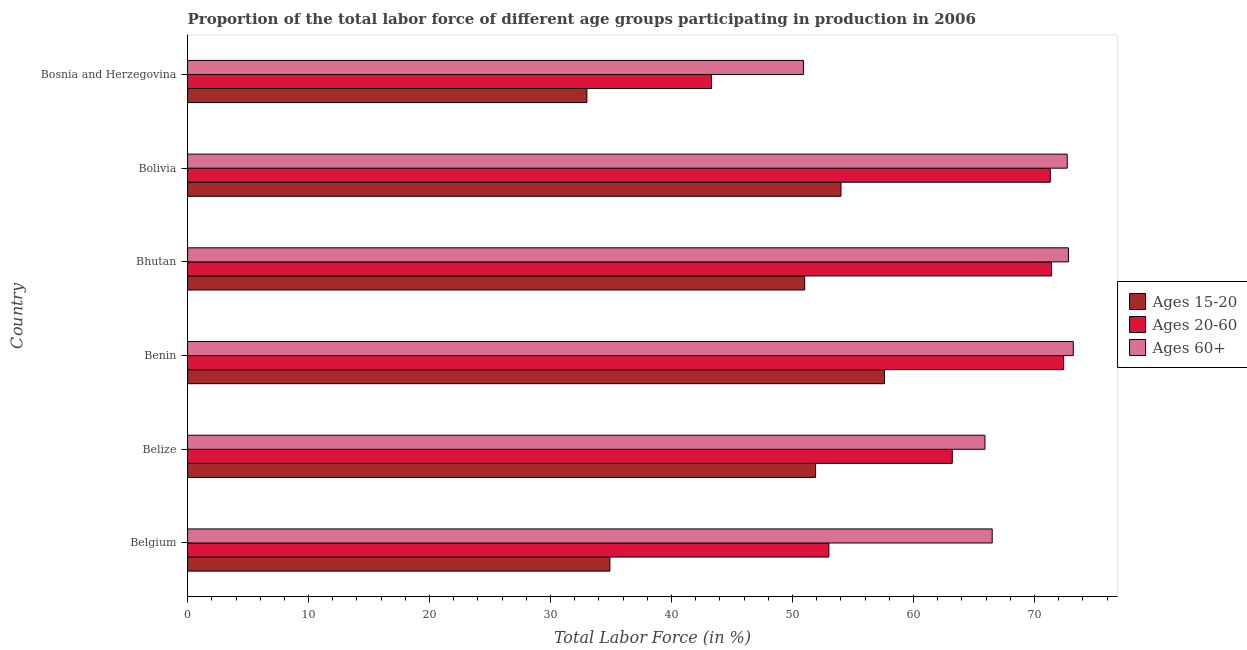How many different coloured bars are there?
Offer a terse response. 3. How many groups of bars are there?
Offer a very short reply. 6. Are the number of bars per tick equal to the number of legend labels?
Offer a very short reply. Yes. How many bars are there on the 5th tick from the top?
Provide a short and direct response. 3. How many bars are there on the 6th tick from the bottom?
Offer a very short reply. 3. What is the label of the 4th group of bars from the top?
Your answer should be very brief. Benin. What is the percentage of labor force within the age group 15-20 in Bosnia and Herzegovina?
Your answer should be very brief. 33. Across all countries, what is the maximum percentage of labor force within the age group 20-60?
Provide a succinct answer. 72.4. In which country was the percentage of labor force within the age group 20-60 maximum?
Your response must be concise. Benin. In which country was the percentage of labor force within the age group 20-60 minimum?
Provide a succinct answer. Bosnia and Herzegovina. What is the total percentage of labor force within the age group 15-20 in the graph?
Make the answer very short. 282.4. What is the difference between the percentage of labor force within the age group 15-20 in Bosnia and Herzegovina and the percentage of labor force within the age group 20-60 in Bolivia?
Make the answer very short. -38.3. What is the average percentage of labor force within the age group 20-60 per country?
Provide a succinct answer. 62.43. What is the difference between the percentage of labor force within the age group 15-20 and percentage of labor force above age 60 in Belize?
Give a very brief answer. -14. In how many countries, is the percentage of labor force within the age group 20-60 greater than 62 %?
Your answer should be very brief. 4. What is the ratio of the percentage of labor force within the age group 15-20 in Belgium to that in Benin?
Make the answer very short. 0.61. Is the percentage of labor force above age 60 in Bhutan less than that in Bosnia and Herzegovina?
Your answer should be compact. No. What is the difference between the highest and the lowest percentage of labor force within the age group 15-20?
Give a very brief answer. 24.6. In how many countries, is the percentage of labor force within the age group 15-20 greater than the average percentage of labor force within the age group 15-20 taken over all countries?
Your response must be concise. 4. What does the 2nd bar from the top in Benin represents?
Your answer should be very brief. Ages 20-60. What does the 3rd bar from the bottom in Bolivia represents?
Offer a terse response. Ages 60+. How many bars are there?
Provide a succinct answer. 18. Are all the bars in the graph horizontal?
Your answer should be very brief. Yes. How many countries are there in the graph?
Ensure brevity in your answer.  6. Where does the legend appear in the graph?
Keep it short and to the point. Center right. How many legend labels are there?
Make the answer very short. 3. What is the title of the graph?
Keep it short and to the point. Proportion of the total labor force of different age groups participating in production in 2006. What is the label or title of the X-axis?
Your response must be concise. Total Labor Force (in %). What is the label or title of the Y-axis?
Your answer should be compact. Country. What is the Total Labor Force (in %) in Ages 15-20 in Belgium?
Keep it short and to the point. 34.9. What is the Total Labor Force (in %) in Ages 60+ in Belgium?
Keep it short and to the point. 66.5. What is the Total Labor Force (in %) of Ages 15-20 in Belize?
Offer a very short reply. 51.9. What is the Total Labor Force (in %) of Ages 20-60 in Belize?
Offer a terse response. 63.2. What is the Total Labor Force (in %) in Ages 60+ in Belize?
Offer a very short reply. 65.9. What is the Total Labor Force (in %) of Ages 15-20 in Benin?
Your response must be concise. 57.6. What is the Total Labor Force (in %) of Ages 20-60 in Benin?
Your answer should be very brief. 72.4. What is the Total Labor Force (in %) in Ages 60+ in Benin?
Your answer should be compact. 73.2. What is the Total Labor Force (in %) in Ages 20-60 in Bhutan?
Offer a terse response. 71.4. What is the Total Labor Force (in %) in Ages 60+ in Bhutan?
Provide a short and direct response. 72.8. What is the Total Labor Force (in %) of Ages 15-20 in Bolivia?
Offer a terse response. 54. What is the Total Labor Force (in %) of Ages 20-60 in Bolivia?
Provide a succinct answer. 71.3. What is the Total Labor Force (in %) in Ages 60+ in Bolivia?
Make the answer very short. 72.7. What is the Total Labor Force (in %) in Ages 20-60 in Bosnia and Herzegovina?
Ensure brevity in your answer.  43.3. What is the Total Labor Force (in %) of Ages 60+ in Bosnia and Herzegovina?
Make the answer very short. 50.9. Across all countries, what is the maximum Total Labor Force (in %) of Ages 15-20?
Give a very brief answer. 57.6. Across all countries, what is the maximum Total Labor Force (in %) in Ages 20-60?
Give a very brief answer. 72.4. Across all countries, what is the maximum Total Labor Force (in %) in Ages 60+?
Keep it short and to the point. 73.2. Across all countries, what is the minimum Total Labor Force (in %) of Ages 20-60?
Your response must be concise. 43.3. Across all countries, what is the minimum Total Labor Force (in %) of Ages 60+?
Ensure brevity in your answer.  50.9. What is the total Total Labor Force (in %) of Ages 15-20 in the graph?
Keep it short and to the point. 282.4. What is the total Total Labor Force (in %) in Ages 20-60 in the graph?
Offer a terse response. 374.6. What is the total Total Labor Force (in %) of Ages 60+ in the graph?
Provide a short and direct response. 402. What is the difference between the Total Labor Force (in %) in Ages 15-20 in Belgium and that in Belize?
Your answer should be very brief. -17. What is the difference between the Total Labor Force (in %) in Ages 20-60 in Belgium and that in Belize?
Offer a terse response. -10.2. What is the difference between the Total Labor Force (in %) in Ages 60+ in Belgium and that in Belize?
Provide a succinct answer. 0.6. What is the difference between the Total Labor Force (in %) in Ages 15-20 in Belgium and that in Benin?
Provide a succinct answer. -22.7. What is the difference between the Total Labor Force (in %) in Ages 20-60 in Belgium and that in Benin?
Give a very brief answer. -19.4. What is the difference between the Total Labor Force (in %) in Ages 15-20 in Belgium and that in Bhutan?
Your answer should be very brief. -16.1. What is the difference between the Total Labor Force (in %) of Ages 20-60 in Belgium and that in Bhutan?
Ensure brevity in your answer.  -18.4. What is the difference between the Total Labor Force (in %) in Ages 15-20 in Belgium and that in Bolivia?
Offer a terse response. -19.1. What is the difference between the Total Labor Force (in %) of Ages 20-60 in Belgium and that in Bolivia?
Keep it short and to the point. -18.3. What is the difference between the Total Labor Force (in %) in Ages 60+ in Belgium and that in Bolivia?
Make the answer very short. -6.2. What is the difference between the Total Labor Force (in %) of Ages 15-20 in Belgium and that in Bosnia and Herzegovina?
Make the answer very short. 1.9. What is the difference between the Total Labor Force (in %) of Ages 20-60 in Belgium and that in Bosnia and Herzegovina?
Keep it short and to the point. 9.7. What is the difference between the Total Labor Force (in %) in Ages 60+ in Belize and that in Benin?
Make the answer very short. -7.3. What is the difference between the Total Labor Force (in %) of Ages 15-20 in Belize and that in Bhutan?
Give a very brief answer. 0.9. What is the difference between the Total Labor Force (in %) of Ages 15-20 in Belize and that in Bolivia?
Your response must be concise. -2.1. What is the difference between the Total Labor Force (in %) of Ages 60+ in Belize and that in Bolivia?
Keep it short and to the point. -6.8. What is the difference between the Total Labor Force (in %) of Ages 15-20 in Benin and that in Bhutan?
Provide a succinct answer. 6.6. What is the difference between the Total Labor Force (in %) of Ages 15-20 in Benin and that in Bolivia?
Provide a succinct answer. 3.6. What is the difference between the Total Labor Force (in %) in Ages 20-60 in Benin and that in Bolivia?
Provide a succinct answer. 1.1. What is the difference between the Total Labor Force (in %) in Ages 15-20 in Benin and that in Bosnia and Herzegovina?
Your response must be concise. 24.6. What is the difference between the Total Labor Force (in %) in Ages 20-60 in Benin and that in Bosnia and Herzegovina?
Your answer should be compact. 29.1. What is the difference between the Total Labor Force (in %) in Ages 60+ in Benin and that in Bosnia and Herzegovina?
Offer a terse response. 22.3. What is the difference between the Total Labor Force (in %) in Ages 15-20 in Bhutan and that in Bolivia?
Your answer should be compact. -3. What is the difference between the Total Labor Force (in %) of Ages 15-20 in Bhutan and that in Bosnia and Herzegovina?
Offer a very short reply. 18. What is the difference between the Total Labor Force (in %) of Ages 20-60 in Bhutan and that in Bosnia and Herzegovina?
Make the answer very short. 28.1. What is the difference between the Total Labor Force (in %) of Ages 60+ in Bhutan and that in Bosnia and Herzegovina?
Provide a succinct answer. 21.9. What is the difference between the Total Labor Force (in %) in Ages 15-20 in Bolivia and that in Bosnia and Herzegovina?
Provide a short and direct response. 21. What is the difference between the Total Labor Force (in %) in Ages 20-60 in Bolivia and that in Bosnia and Herzegovina?
Offer a terse response. 28. What is the difference between the Total Labor Force (in %) of Ages 60+ in Bolivia and that in Bosnia and Herzegovina?
Offer a terse response. 21.8. What is the difference between the Total Labor Force (in %) in Ages 15-20 in Belgium and the Total Labor Force (in %) in Ages 20-60 in Belize?
Provide a short and direct response. -28.3. What is the difference between the Total Labor Force (in %) in Ages 15-20 in Belgium and the Total Labor Force (in %) in Ages 60+ in Belize?
Give a very brief answer. -31. What is the difference between the Total Labor Force (in %) of Ages 20-60 in Belgium and the Total Labor Force (in %) of Ages 60+ in Belize?
Offer a very short reply. -12.9. What is the difference between the Total Labor Force (in %) in Ages 15-20 in Belgium and the Total Labor Force (in %) in Ages 20-60 in Benin?
Provide a succinct answer. -37.5. What is the difference between the Total Labor Force (in %) in Ages 15-20 in Belgium and the Total Labor Force (in %) in Ages 60+ in Benin?
Make the answer very short. -38.3. What is the difference between the Total Labor Force (in %) of Ages 20-60 in Belgium and the Total Labor Force (in %) of Ages 60+ in Benin?
Ensure brevity in your answer.  -20.2. What is the difference between the Total Labor Force (in %) in Ages 15-20 in Belgium and the Total Labor Force (in %) in Ages 20-60 in Bhutan?
Make the answer very short. -36.5. What is the difference between the Total Labor Force (in %) in Ages 15-20 in Belgium and the Total Labor Force (in %) in Ages 60+ in Bhutan?
Your answer should be very brief. -37.9. What is the difference between the Total Labor Force (in %) of Ages 20-60 in Belgium and the Total Labor Force (in %) of Ages 60+ in Bhutan?
Offer a very short reply. -19.8. What is the difference between the Total Labor Force (in %) in Ages 15-20 in Belgium and the Total Labor Force (in %) in Ages 20-60 in Bolivia?
Your answer should be compact. -36.4. What is the difference between the Total Labor Force (in %) of Ages 15-20 in Belgium and the Total Labor Force (in %) of Ages 60+ in Bolivia?
Offer a terse response. -37.8. What is the difference between the Total Labor Force (in %) of Ages 20-60 in Belgium and the Total Labor Force (in %) of Ages 60+ in Bolivia?
Make the answer very short. -19.7. What is the difference between the Total Labor Force (in %) of Ages 15-20 in Belgium and the Total Labor Force (in %) of Ages 20-60 in Bosnia and Herzegovina?
Your answer should be compact. -8.4. What is the difference between the Total Labor Force (in %) in Ages 15-20 in Belgium and the Total Labor Force (in %) in Ages 60+ in Bosnia and Herzegovina?
Make the answer very short. -16. What is the difference between the Total Labor Force (in %) in Ages 20-60 in Belgium and the Total Labor Force (in %) in Ages 60+ in Bosnia and Herzegovina?
Offer a terse response. 2.1. What is the difference between the Total Labor Force (in %) of Ages 15-20 in Belize and the Total Labor Force (in %) of Ages 20-60 in Benin?
Make the answer very short. -20.5. What is the difference between the Total Labor Force (in %) in Ages 15-20 in Belize and the Total Labor Force (in %) in Ages 60+ in Benin?
Ensure brevity in your answer.  -21.3. What is the difference between the Total Labor Force (in %) of Ages 15-20 in Belize and the Total Labor Force (in %) of Ages 20-60 in Bhutan?
Your response must be concise. -19.5. What is the difference between the Total Labor Force (in %) in Ages 15-20 in Belize and the Total Labor Force (in %) in Ages 60+ in Bhutan?
Provide a short and direct response. -20.9. What is the difference between the Total Labor Force (in %) in Ages 20-60 in Belize and the Total Labor Force (in %) in Ages 60+ in Bhutan?
Ensure brevity in your answer.  -9.6. What is the difference between the Total Labor Force (in %) in Ages 15-20 in Belize and the Total Labor Force (in %) in Ages 20-60 in Bolivia?
Provide a succinct answer. -19.4. What is the difference between the Total Labor Force (in %) in Ages 15-20 in Belize and the Total Labor Force (in %) in Ages 60+ in Bolivia?
Provide a succinct answer. -20.8. What is the difference between the Total Labor Force (in %) in Ages 20-60 in Belize and the Total Labor Force (in %) in Ages 60+ in Bolivia?
Give a very brief answer. -9.5. What is the difference between the Total Labor Force (in %) of Ages 20-60 in Belize and the Total Labor Force (in %) of Ages 60+ in Bosnia and Herzegovina?
Offer a very short reply. 12.3. What is the difference between the Total Labor Force (in %) in Ages 15-20 in Benin and the Total Labor Force (in %) in Ages 60+ in Bhutan?
Give a very brief answer. -15.2. What is the difference between the Total Labor Force (in %) of Ages 20-60 in Benin and the Total Labor Force (in %) of Ages 60+ in Bhutan?
Keep it short and to the point. -0.4. What is the difference between the Total Labor Force (in %) of Ages 15-20 in Benin and the Total Labor Force (in %) of Ages 20-60 in Bolivia?
Offer a very short reply. -13.7. What is the difference between the Total Labor Force (in %) in Ages 15-20 in Benin and the Total Labor Force (in %) in Ages 60+ in Bolivia?
Offer a very short reply. -15.1. What is the difference between the Total Labor Force (in %) of Ages 15-20 in Benin and the Total Labor Force (in %) of Ages 20-60 in Bosnia and Herzegovina?
Provide a succinct answer. 14.3. What is the difference between the Total Labor Force (in %) of Ages 15-20 in Bhutan and the Total Labor Force (in %) of Ages 20-60 in Bolivia?
Keep it short and to the point. -20.3. What is the difference between the Total Labor Force (in %) in Ages 15-20 in Bhutan and the Total Labor Force (in %) in Ages 60+ in Bolivia?
Ensure brevity in your answer.  -21.7. What is the difference between the Total Labor Force (in %) of Ages 15-20 in Bolivia and the Total Labor Force (in %) of Ages 20-60 in Bosnia and Herzegovina?
Make the answer very short. 10.7. What is the difference between the Total Labor Force (in %) of Ages 20-60 in Bolivia and the Total Labor Force (in %) of Ages 60+ in Bosnia and Herzegovina?
Provide a short and direct response. 20.4. What is the average Total Labor Force (in %) of Ages 15-20 per country?
Offer a very short reply. 47.07. What is the average Total Labor Force (in %) of Ages 20-60 per country?
Make the answer very short. 62.43. What is the difference between the Total Labor Force (in %) in Ages 15-20 and Total Labor Force (in %) in Ages 20-60 in Belgium?
Provide a succinct answer. -18.1. What is the difference between the Total Labor Force (in %) in Ages 15-20 and Total Labor Force (in %) in Ages 60+ in Belgium?
Your response must be concise. -31.6. What is the difference between the Total Labor Force (in %) of Ages 15-20 and Total Labor Force (in %) of Ages 60+ in Belize?
Provide a short and direct response. -14. What is the difference between the Total Labor Force (in %) of Ages 15-20 and Total Labor Force (in %) of Ages 20-60 in Benin?
Provide a short and direct response. -14.8. What is the difference between the Total Labor Force (in %) in Ages 15-20 and Total Labor Force (in %) in Ages 60+ in Benin?
Your answer should be compact. -15.6. What is the difference between the Total Labor Force (in %) in Ages 20-60 and Total Labor Force (in %) in Ages 60+ in Benin?
Your answer should be compact. -0.8. What is the difference between the Total Labor Force (in %) of Ages 15-20 and Total Labor Force (in %) of Ages 20-60 in Bhutan?
Ensure brevity in your answer.  -20.4. What is the difference between the Total Labor Force (in %) of Ages 15-20 and Total Labor Force (in %) of Ages 60+ in Bhutan?
Provide a succinct answer. -21.8. What is the difference between the Total Labor Force (in %) in Ages 20-60 and Total Labor Force (in %) in Ages 60+ in Bhutan?
Give a very brief answer. -1.4. What is the difference between the Total Labor Force (in %) in Ages 15-20 and Total Labor Force (in %) in Ages 20-60 in Bolivia?
Offer a very short reply. -17.3. What is the difference between the Total Labor Force (in %) in Ages 15-20 and Total Labor Force (in %) in Ages 60+ in Bolivia?
Provide a succinct answer. -18.7. What is the difference between the Total Labor Force (in %) of Ages 20-60 and Total Labor Force (in %) of Ages 60+ in Bolivia?
Your answer should be very brief. -1.4. What is the difference between the Total Labor Force (in %) of Ages 15-20 and Total Labor Force (in %) of Ages 60+ in Bosnia and Herzegovina?
Your answer should be very brief. -17.9. What is the difference between the Total Labor Force (in %) in Ages 20-60 and Total Labor Force (in %) in Ages 60+ in Bosnia and Herzegovina?
Your response must be concise. -7.6. What is the ratio of the Total Labor Force (in %) of Ages 15-20 in Belgium to that in Belize?
Provide a succinct answer. 0.67. What is the ratio of the Total Labor Force (in %) in Ages 20-60 in Belgium to that in Belize?
Keep it short and to the point. 0.84. What is the ratio of the Total Labor Force (in %) in Ages 60+ in Belgium to that in Belize?
Provide a short and direct response. 1.01. What is the ratio of the Total Labor Force (in %) of Ages 15-20 in Belgium to that in Benin?
Offer a terse response. 0.61. What is the ratio of the Total Labor Force (in %) of Ages 20-60 in Belgium to that in Benin?
Ensure brevity in your answer.  0.73. What is the ratio of the Total Labor Force (in %) of Ages 60+ in Belgium to that in Benin?
Provide a succinct answer. 0.91. What is the ratio of the Total Labor Force (in %) in Ages 15-20 in Belgium to that in Bhutan?
Give a very brief answer. 0.68. What is the ratio of the Total Labor Force (in %) in Ages 20-60 in Belgium to that in Bhutan?
Your response must be concise. 0.74. What is the ratio of the Total Labor Force (in %) in Ages 60+ in Belgium to that in Bhutan?
Your response must be concise. 0.91. What is the ratio of the Total Labor Force (in %) in Ages 15-20 in Belgium to that in Bolivia?
Your answer should be very brief. 0.65. What is the ratio of the Total Labor Force (in %) in Ages 20-60 in Belgium to that in Bolivia?
Offer a terse response. 0.74. What is the ratio of the Total Labor Force (in %) in Ages 60+ in Belgium to that in Bolivia?
Provide a succinct answer. 0.91. What is the ratio of the Total Labor Force (in %) in Ages 15-20 in Belgium to that in Bosnia and Herzegovina?
Provide a succinct answer. 1.06. What is the ratio of the Total Labor Force (in %) of Ages 20-60 in Belgium to that in Bosnia and Herzegovina?
Keep it short and to the point. 1.22. What is the ratio of the Total Labor Force (in %) in Ages 60+ in Belgium to that in Bosnia and Herzegovina?
Provide a short and direct response. 1.31. What is the ratio of the Total Labor Force (in %) of Ages 15-20 in Belize to that in Benin?
Make the answer very short. 0.9. What is the ratio of the Total Labor Force (in %) of Ages 20-60 in Belize to that in Benin?
Offer a very short reply. 0.87. What is the ratio of the Total Labor Force (in %) of Ages 60+ in Belize to that in Benin?
Offer a terse response. 0.9. What is the ratio of the Total Labor Force (in %) in Ages 15-20 in Belize to that in Bhutan?
Your answer should be compact. 1.02. What is the ratio of the Total Labor Force (in %) in Ages 20-60 in Belize to that in Bhutan?
Provide a short and direct response. 0.89. What is the ratio of the Total Labor Force (in %) in Ages 60+ in Belize to that in Bhutan?
Give a very brief answer. 0.91. What is the ratio of the Total Labor Force (in %) in Ages 15-20 in Belize to that in Bolivia?
Give a very brief answer. 0.96. What is the ratio of the Total Labor Force (in %) in Ages 20-60 in Belize to that in Bolivia?
Offer a terse response. 0.89. What is the ratio of the Total Labor Force (in %) in Ages 60+ in Belize to that in Bolivia?
Offer a terse response. 0.91. What is the ratio of the Total Labor Force (in %) in Ages 15-20 in Belize to that in Bosnia and Herzegovina?
Ensure brevity in your answer.  1.57. What is the ratio of the Total Labor Force (in %) in Ages 20-60 in Belize to that in Bosnia and Herzegovina?
Give a very brief answer. 1.46. What is the ratio of the Total Labor Force (in %) in Ages 60+ in Belize to that in Bosnia and Herzegovina?
Your response must be concise. 1.29. What is the ratio of the Total Labor Force (in %) in Ages 15-20 in Benin to that in Bhutan?
Keep it short and to the point. 1.13. What is the ratio of the Total Labor Force (in %) of Ages 20-60 in Benin to that in Bhutan?
Make the answer very short. 1.01. What is the ratio of the Total Labor Force (in %) of Ages 60+ in Benin to that in Bhutan?
Offer a terse response. 1.01. What is the ratio of the Total Labor Force (in %) in Ages 15-20 in Benin to that in Bolivia?
Your response must be concise. 1.07. What is the ratio of the Total Labor Force (in %) of Ages 20-60 in Benin to that in Bolivia?
Offer a very short reply. 1.02. What is the ratio of the Total Labor Force (in %) of Ages 15-20 in Benin to that in Bosnia and Herzegovina?
Provide a short and direct response. 1.75. What is the ratio of the Total Labor Force (in %) of Ages 20-60 in Benin to that in Bosnia and Herzegovina?
Keep it short and to the point. 1.67. What is the ratio of the Total Labor Force (in %) in Ages 60+ in Benin to that in Bosnia and Herzegovina?
Ensure brevity in your answer.  1.44. What is the ratio of the Total Labor Force (in %) in Ages 20-60 in Bhutan to that in Bolivia?
Provide a short and direct response. 1. What is the ratio of the Total Labor Force (in %) of Ages 15-20 in Bhutan to that in Bosnia and Herzegovina?
Ensure brevity in your answer.  1.55. What is the ratio of the Total Labor Force (in %) in Ages 20-60 in Bhutan to that in Bosnia and Herzegovina?
Provide a succinct answer. 1.65. What is the ratio of the Total Labor Force (in %) of Ages 60+ in Bhutan to that in Bosnia and Herzegovina?
Ensure brevity in your answer.  1.43. What is the ratio of the Total Labor Force (in %) in Ages 15-20 in Bolivia to that in Bosnia and Herzegovina?
Make the answer very short. 1.64. What is the ratio of the Total Labor Force (in %) of Ages 20-60 in Bolivia to that in Bosnia and Herzegovina?
Make the answer very short. 1.65. What is the ratio of the Total Labor Force (in %) in Ages 60+ in Bolivia to that in Bosnia and Herzegovina?
Ensure brevity in your answer.  1.43. What is the difference between the highest and the second highest Total Labor Force (in %) in Ages 15-20?
Provide a succinct answer. 3.6. What is the difference between the highest and the second highest Total Labor Force (in %) of Ages 20-60?
Keep it short and to the point. 1. What is the difference between the highest and the second highest Total Labor Force (in %) in Ages 60+?
Make the answer very short. 0.4. What is the difference between the highest and the lowest Total Labor Force (in %) of Ages 15-20?
Keep it short and to the point. 24.6. What is the difference between the highest and the lowest Total Labor Force (in %) in Ages 20-60?
Ensure brevity in your answer.  29.1. What is the difference between the highest and the lowest Total Labor Force (in %) of Ages 60+?
Your answer should be very brief. 22.3. 